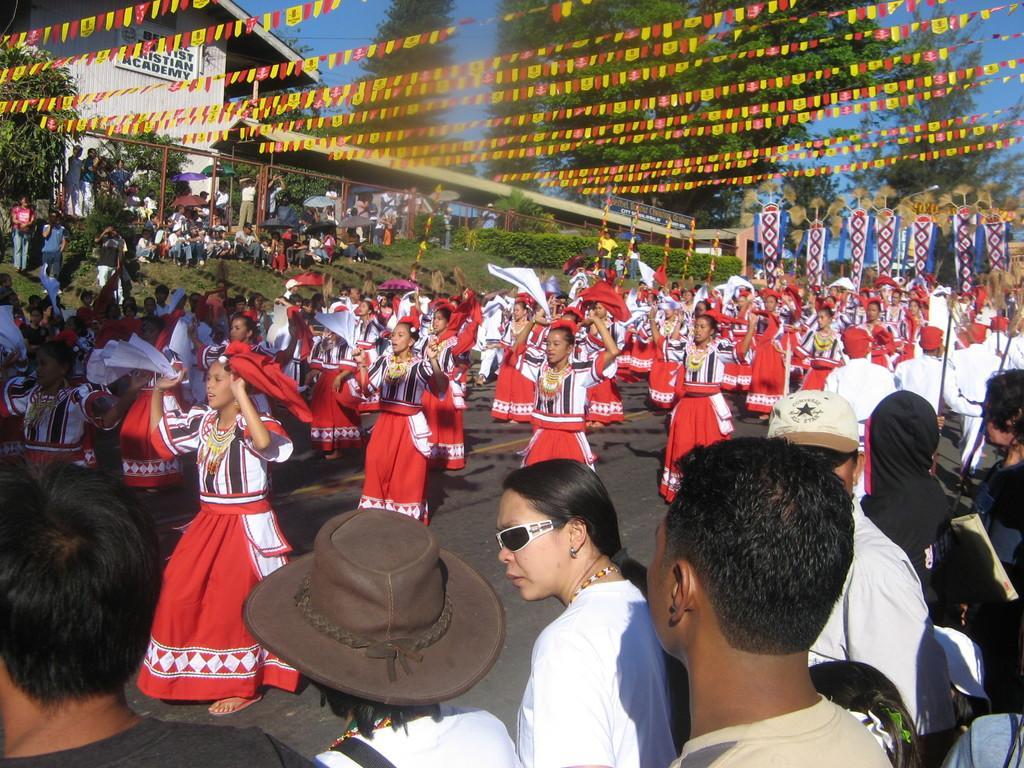Please provide a concise description of this image. In this picture we can see some people dancing here, on the right side there are some people standing here, we can see ribbons here, in the background there are some trees, we can see clothes here, there is a building where, we can see grass where, there is the sky at the top of the picture. 